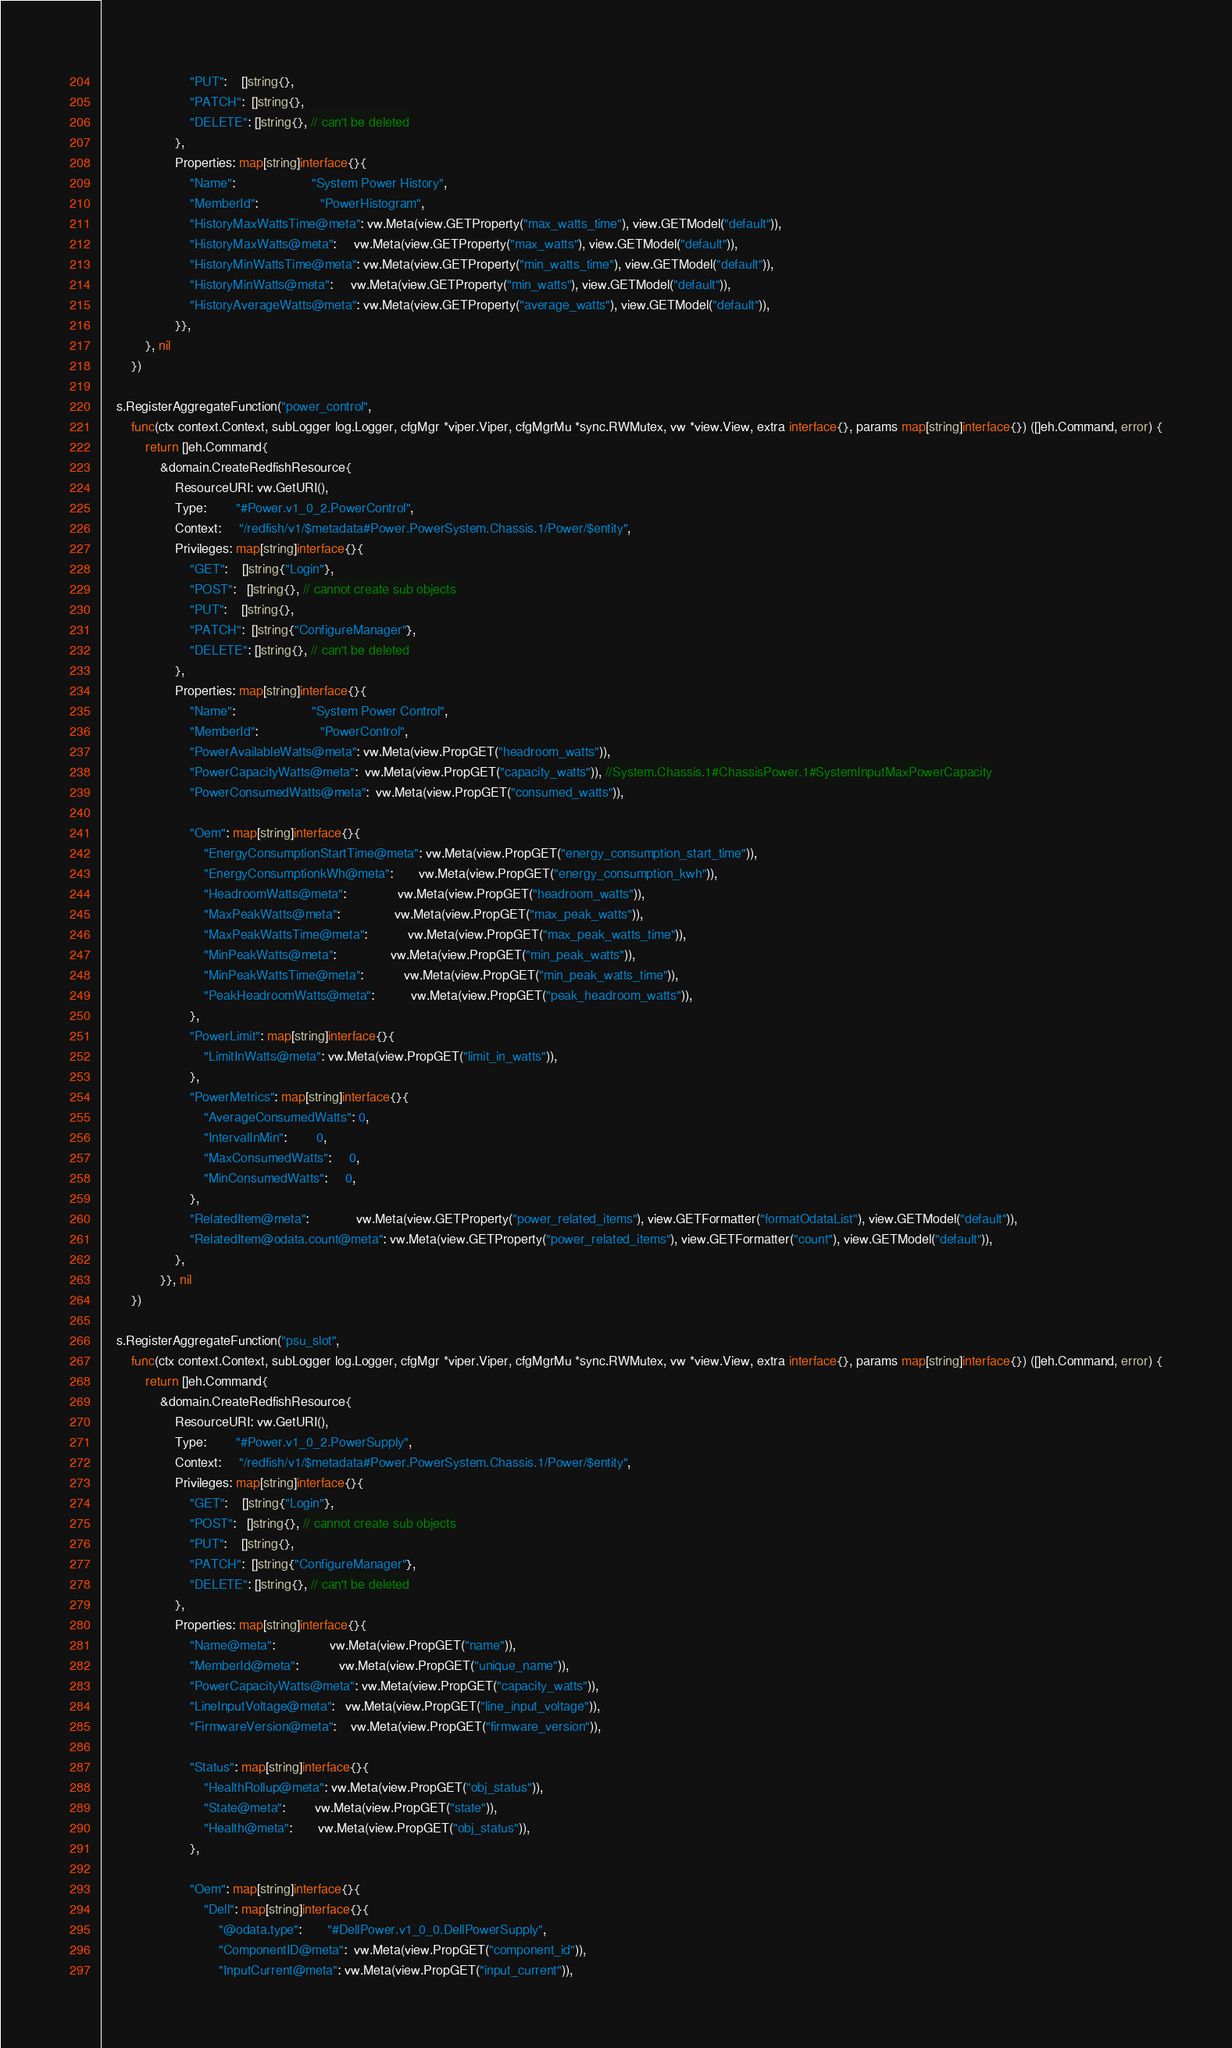<code> <loc_0><loc_0><loc_500><loc_500><_Go_>						"PUT":    []string{},
						"PATCH":  []string{},
						"DELETE": []string{}, // can't be deleted
					},
					Properties: map[string]interface{}{
						"Name":                     "System Power History",
						"MemberId":                 "PowerHistogram",
						"HistoryMaxWattsTime@meta": vw.Meta(view.GETProperty("max_watts_time"), view.GETModel("default")),
						"HistoryMaxWatts@meta":     vw.Meta(view.GETProperty("max_watts"), view.GETModel("default")),
						"HistoryMinWattsTime@meta": vw.Meta(view.GETProperty("min_watts_time"), view.GETModel("default")),
						"HistoryMinWatts@meta":     vw.Meta(view.GETProperty("min_watts"), view.GETModel("default")),
						"HistoryAverageWatts@meta": vw.Meta(view.GETProperty("average_watts"), view.GETModel("default")),
					}},
			}, nil
		})

	s.RegisterAggregateFunction("power_control",
		func(ctx context.Context, subLogger log.Logger, cfgMgr *viper.Viper, cfgMgrMu *sync.RWMutex, vw *view.View, extra interface{}, params map[string]interface{}) ([]eh.Command, error) {
			return []eh.Command{
				&domain.CreateRedfishResource{
					ResourceURI: vw.GetURI(),
					Type:        "#Power.v1_0_2.PowerControl",
					Context:     "/redfish/v1/$metadata#Power.PowerSystem.Chassis.1/Power/$entity",
					Privileges: map[string]interface{}{
						"GET":    []string{"Login"},
						"POST":   []string{}, // cannot create sub objects
						"PUT":    []string{},
						"PATCH":  []string{"ConfigureManager"},
						"DELETE": []string{}, // can't be deleted
					},
					Properties: map[string]interface{}{
						"Name":                     "System Power Control",
						"MemberId":                 "PowerControl",
						"PowerAvailableWatts@meta": vw.Meta(view.PropGET("headroom_watts")),
						"PowerCapacityWatts@meta":  vw.Meta(view.PropGET("capacity_watts")), //System.Chassis.1#ChassisPower.1#SystemInputMaxPowerCapacity
						"PowerConsumedWatts@meta":  vw.Meta(view.PropGET("consumed_watts")),

						"Oem": map[string]interface{}{
							"EnergyConsumptionStartTime@meta": vw.Meta(view.PropGET("energy_consumption_start_time")),
							"EnergyConsumptionkWh@meta":       vw.Meta(view.PropGET("energy_consumption_kwh")),
							"HeadroomWatts@meta":              vw.Meta(view.PropGET("headroom_watts")),
							"MaxPeakWatts@meta":               vw.Meta(view.PropGET("max_peak_watts")),
							"MaxPeakWattsTime@meta":           vw.Meta(view.PropGET("max_peak_watts_time")),
							"MinPeakWatts@meta":               vw.Meta(view.PropGET("min_peak_watts")),
							"MinPeakWattsTime@meta":           vw.Meta(view.PropGET("min_peak_watts_time")),
							"PeakHeadroomWatts@meta":          vw.Meta(view.PropGET("peak_headroom_watts")),
						},
						"PowerLimit": map[string]interface{}{
							"LimitInWatts@meta": vw.Meta(view.PropGET("limit_in_watts")),
						},
						"PowerMetrics": map[string]interface{}{
							"AverageConsumedWatts": 0,
							"IntervalInMin":        0,
							"MaxConsumedWatts":     0,
							"MinConsumedWatts":     0,
						},
						"RelatedItem@meta":             vw.Meta(view.GETProperty("power_related_items"), view.GETFormatter("formatOdataList"), view.GETModel("default")),
						"RelatedItem@odata.count@meta": vw.Meta(view.GETProperty("power_related_items"), view.GETFormatter("count"), view.GETModel("default")),
					},
				}}, nil
		})

	s.RegisterAggregateFunction("psu_slot",
		func(ctx context.Context, subLogger log.Logger, cfgMgr *viper.Viper, cfgMgrMu *sync.RWMutex, vw *view.View, extra interface{}, params map[string]interface{}) ([]eh.Command, error) {
			return []eh.Command{
				&domain.CreateRedfishResource{
					ResourceURI: vw.GetURI(),
					Type:        "#Power.v1_0_2.PowerSupply",
					Context:     "/redfish/v1/$metadata#Power.PowerSystem.Chassis.1/Power/$entity",
					Privileges: map[string]interface{}{
						"GET":    []string{"Login"},
						"POST":   []string{}, // cannot create sub objects
						"PUT":    []string{},
						"PATCH":  []string{"ConfigureManager"},
						"DELETE": []string{}, // can't be deleted
					},
					Properties: map[string]interface{}{
						"Name@meta":               vw.Meta(view.PropGET("name")),
						"MemberId@meta":           vw.Meta(view.PropGET("unique_name")),
						"PowerCapacityWatts@meta": vw.Meta(view.PropGET("capacity_watts")),
						"LineInputVoltage@meta":   vw.Meta(view.PropGET("line_input_voltage")),
						"FirmwareVersion@meta":    vw.Meta(view.PropGET("firmware_version")),

						"Status": map[string]interface{}{
							"HealthRollup@meta": vw.Meta(view.PropGET("obj_status")),
							"State@meta":        vw.Meta(view.PropGET("state")),
							"Health@meta":       vw.Meta(view.PropGET("obj_status")),
						},

						"Oem": map[string]interface{}{
							"Dell": map[string]interface{}{
								"@odata.type":       "#DellPower.v1_0_0.DellPowerSupply",
								"ComponentID@meta":  vw.Meta(view.PropGET("component_id")),
								"InputCurrent@meta": vw.Meta(view.PropGET("input_current")),</code> 